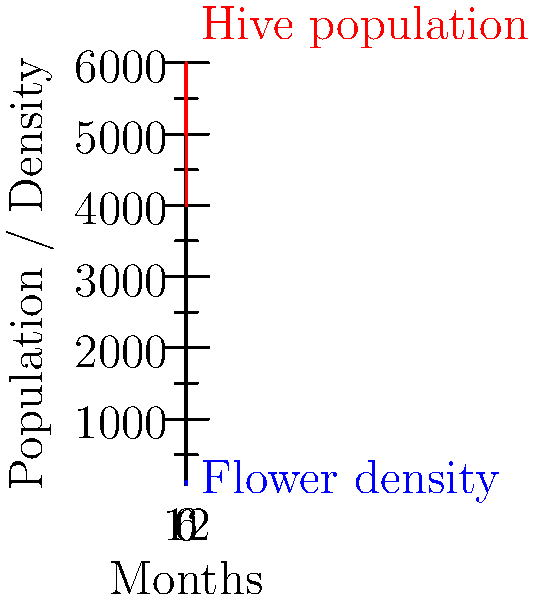Based on the graph showing hive population and flower density over a 12-month period, during which month is honey production likely to be at its peak? Assume that honey production is directly proportional to both hive population and flower density. To determine the month of peak honey production, we need to analyze both the hive population and flower density curves, as honey production is directly proportional to both factors. Let's follow these steps:

1. Observe that the hive population (red curve) follows a sinusoidal pattern with a period of 12 months, peaking around the 3-month and 9-month marks.

2. The flower density (blue curve) also follows a sinusoidal pattern with a 12-month period, but it's out of phase with the hive population. It peaks around the 6-month mark.

3. Since honey production is proportional to both factors, we need to find where the product of these two curves is at its maximum.

4. Visually, this occurs where both curves are relatively high, which is around the 4.5-month mark.

5. At this point, the hive population is still high (though slightly past its peak), and the flower density is increasing rapidly.

6. Converting 4.5 months to the nearest whole month, we arrive at month 5.

Therefore, honey production is likely to peak during the 5th month of the year.
Answer: Month 5 